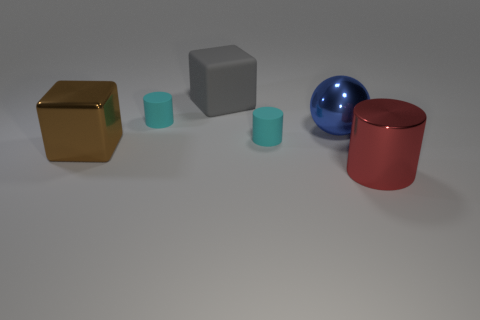How do the materials of these objects differ? The gold cube appears to have a reflective and shiny surface, suggesting a metallic material. The gray cube and the matte cyan cylinder seem to have a dull or non-reflective surface, which is indicative of a matte material. The blue sphere and the red, matte cylinder exhibit a slight shine, suggesting they might be made of plastic or polished material. 